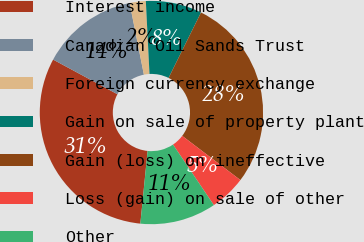Convert chart. <chart><loc_0><loc_0><loc_500><loc_500><pie_chart><fcel>Interest income<fcel>Canadian Oil Sands Trust<fcel>Foreign currency exchange<fcel>Gain on sale of property plant<fcel>Gain (loss) on ineffective<fcel>Loss (gain) on sale of other<fcel>Other<nl><fcel>31.28%<fcel>14.01%<fcel>2.33%<fcel>8.12%<fcel>28.01%<fcel>5.23%<fcel>11.02%<nl></chart> 